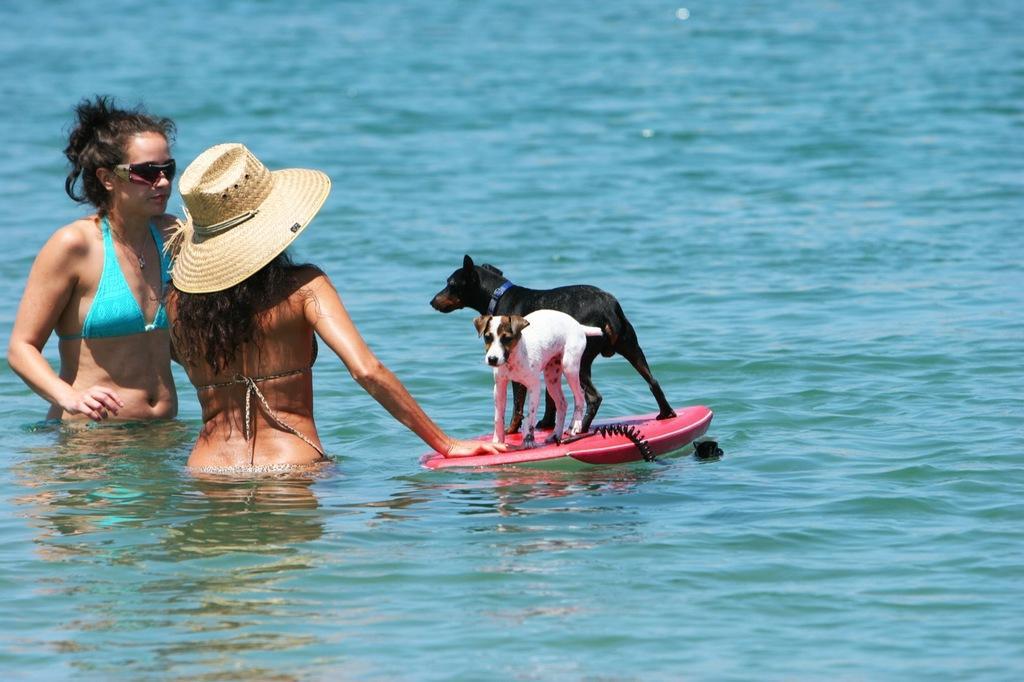In one or two sentences, can you explain what this image depicts? As we can see in the image there are two women and two dogs standing on surfboard. There is water. The dog standing in the front is in white color and the other dog is in black color. 